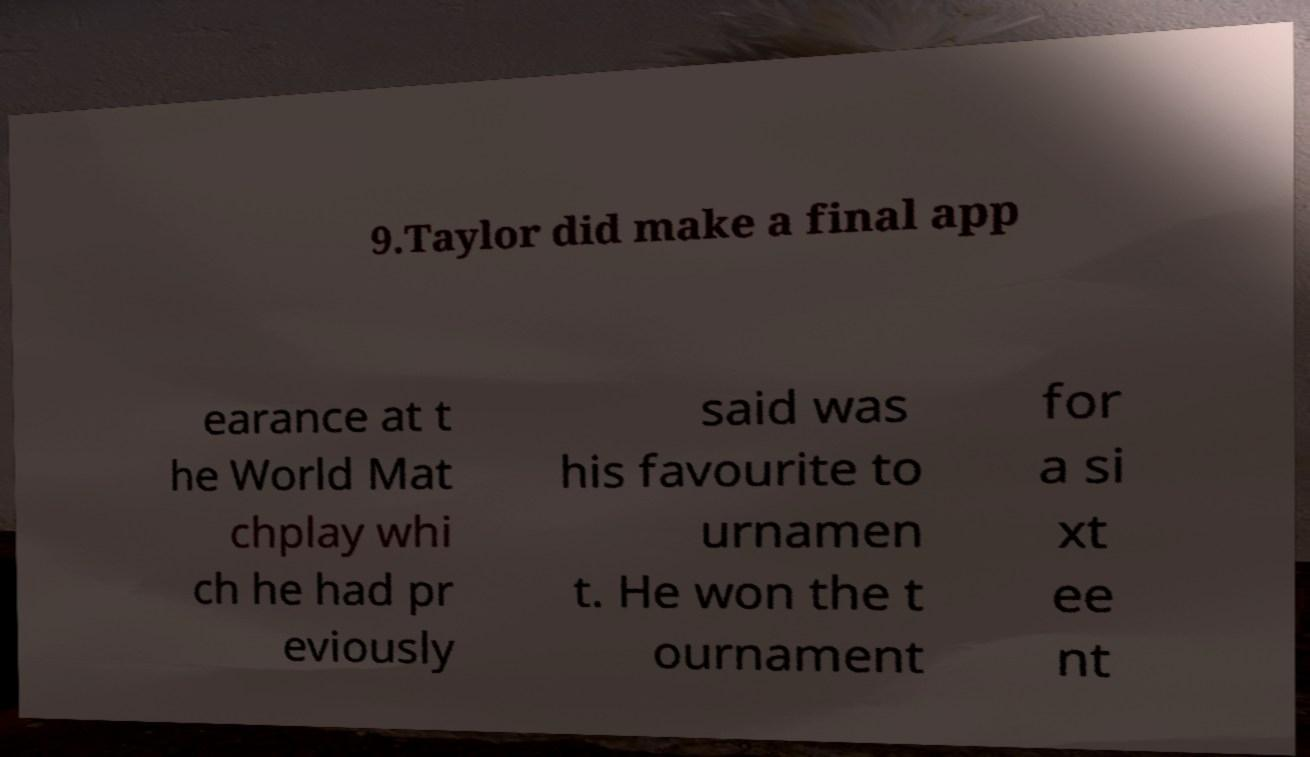Please read and relay the text visible in this image. What does it say? 9.Taylor did make a final app earance at t he World Mat chplay whi ch he had pr eviously said was his favourite to urnamen t. He won the t ournament for a si xt ee nt 